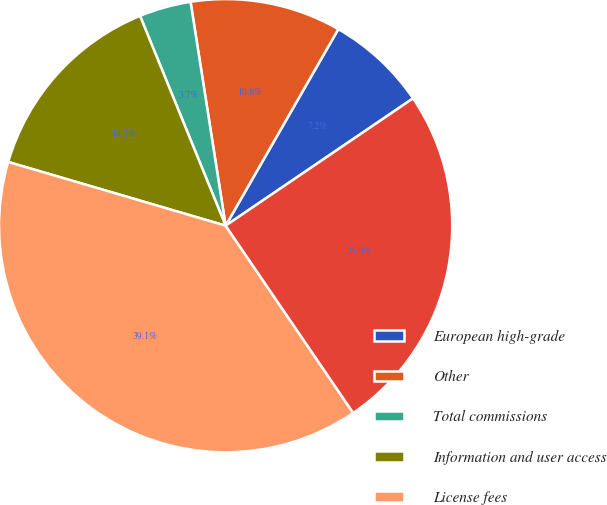Convert chart to OTSL. <chart><loc_0><loc_0><loc_500><loc_500><pie_chart><fcel>European high-grade<fcel>Other<fcel>Total commissions<fcel>Information and user access<fcel>License fees<fcel>Investment income<nl><fcel>7.22%<fcel>10.76%<fcel>3.69%<fcel>14.3%<fcel>39.06%<fcel>24.98%<nl></chart> 